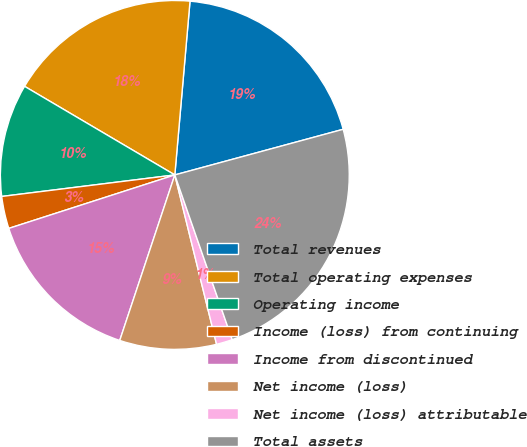Convert chart to OTSL. <chart><loc_0><loc_0><loc_500><loc_500><pie_chart><fcel>Total revenues<fcel>Total operating expenses<fcel>Operating income<fcel>Income (loss) from continuing<fcel>Income from discontinued<fcel>Net income (loss)<fcel>Net income (loss) attributable<fcel>Total assets<nl><fcel>19.4%<fcel>17.91%<fcel>10.45%<fcel>2.99%<fcel>14.93%<fcel>8.96%<fcel>1.49%<fcel>23.88%<nl></chart> 